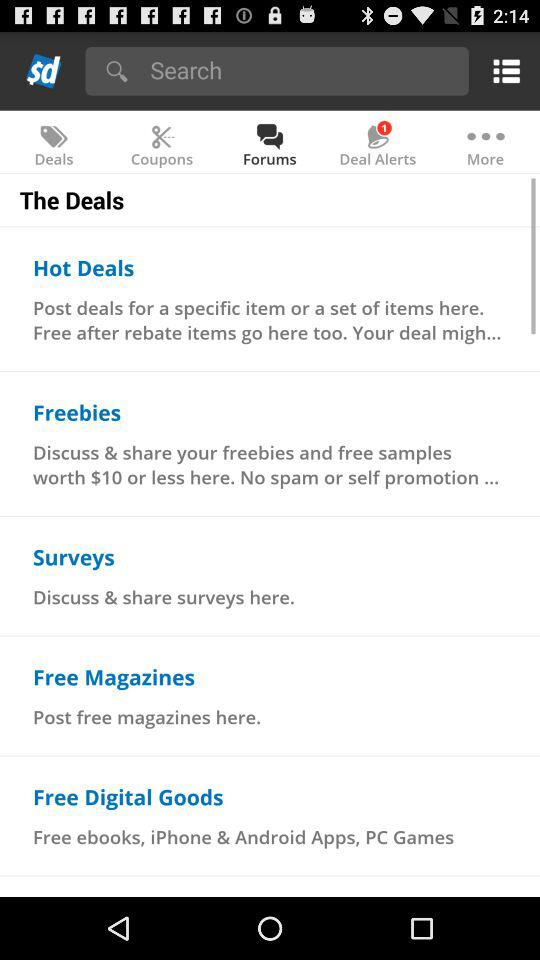What is the price of free samples? The price of free samples is $10 or less. 